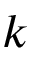Convert formula to latex. <formula><loc_0><loc_0><loc_500><loc_500>k</formula> 